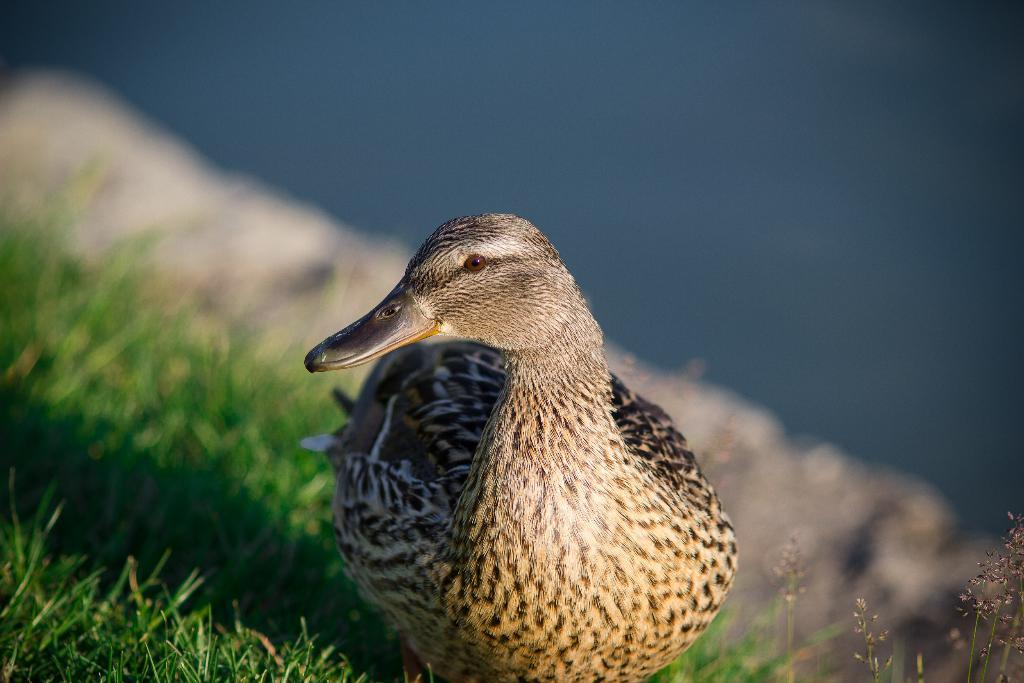What type of animal can be seen in the picture? There is a bird in the picture. What type of vegetation is visible in the picture? There is grass visible in the picture. How would you describe the background of the image? The background of the image is blurry. What type of brick can be seen in the picture? There is no brick present in the picture; it features a bird and grass. How does the bird sneeze in the picture? Birds do not sneeze, and there is no indication of any sneezing in the image. 